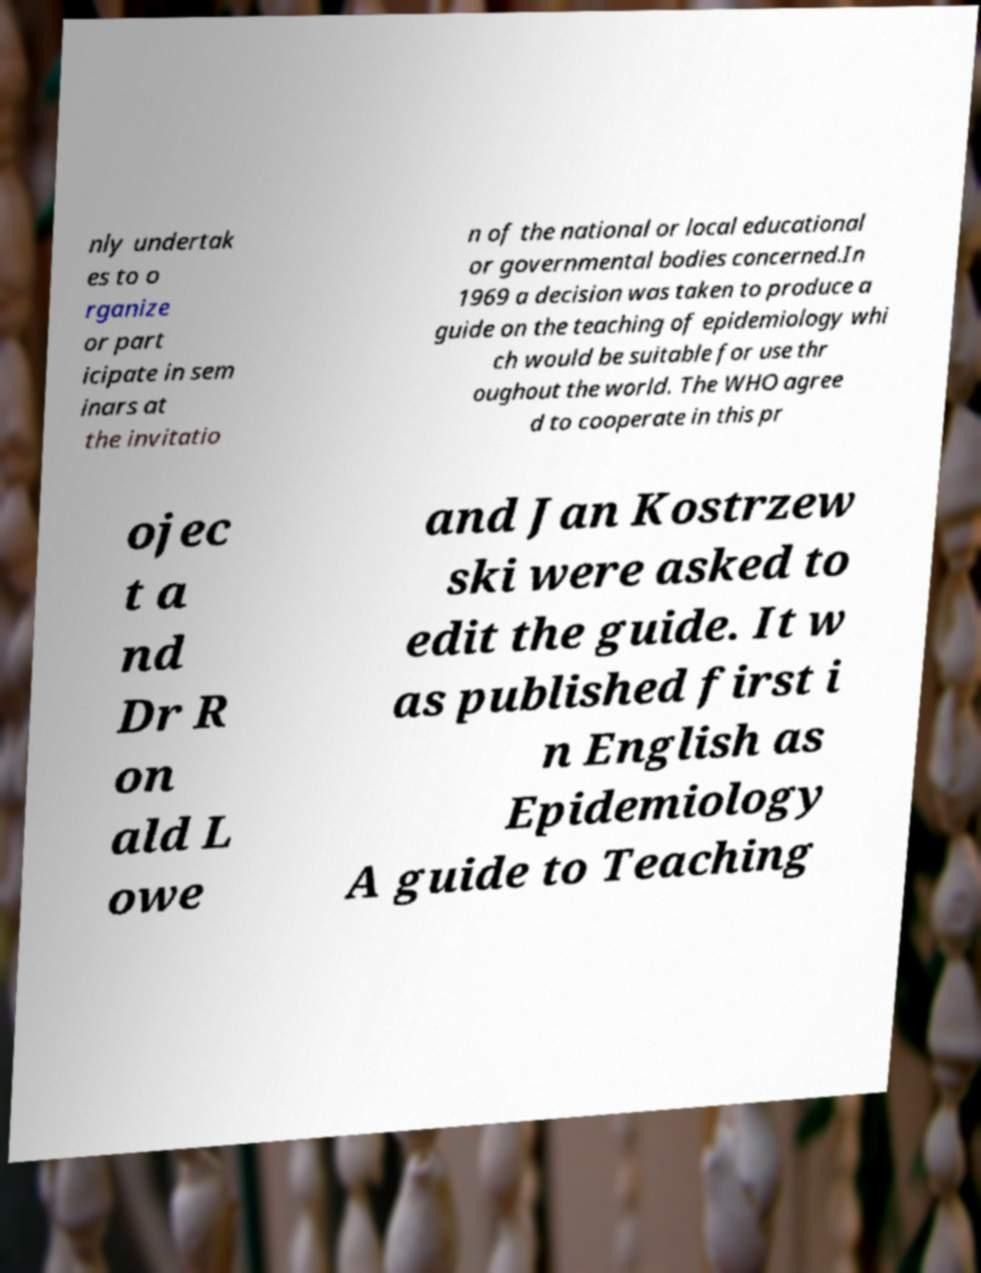What messages or text are displayed in this image? I need them in a readable, typed format. nly undertak es to o rganize or part icipate in sem inars at the invitatio n of the national or local educational or governmental bodies concerned.In 1969 a decision was taken to produce a guide on the teaching of epidemiology whi ch would be suitable for use thr oughout the world. The WHO agree d to cooperate in this pr ojec t a nd Dr R on ald L owe and Jan Kostrzew ski were asked to edit the guide. It w as published first i n English as Epidemiology A guide to Teaching 